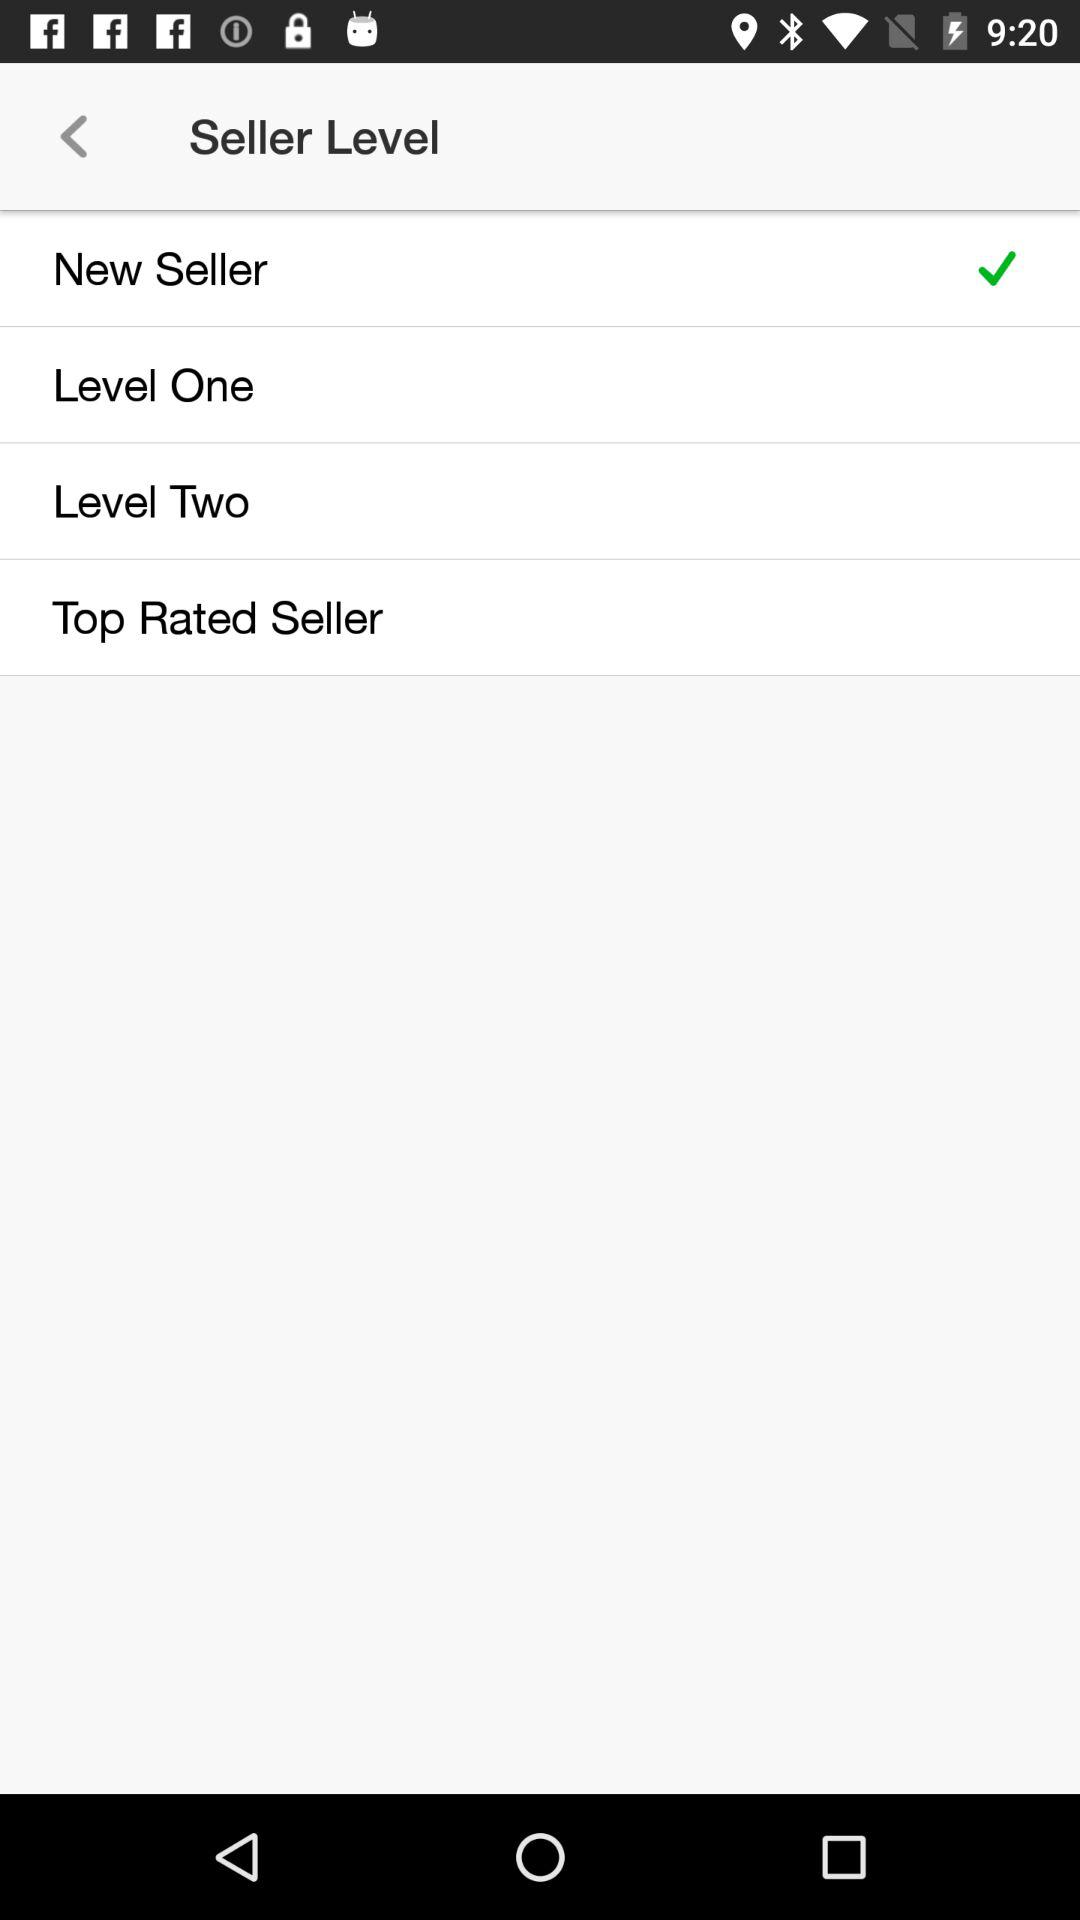How many seller levels have a check mark?
Answer the question using a single word or phrase. 1 